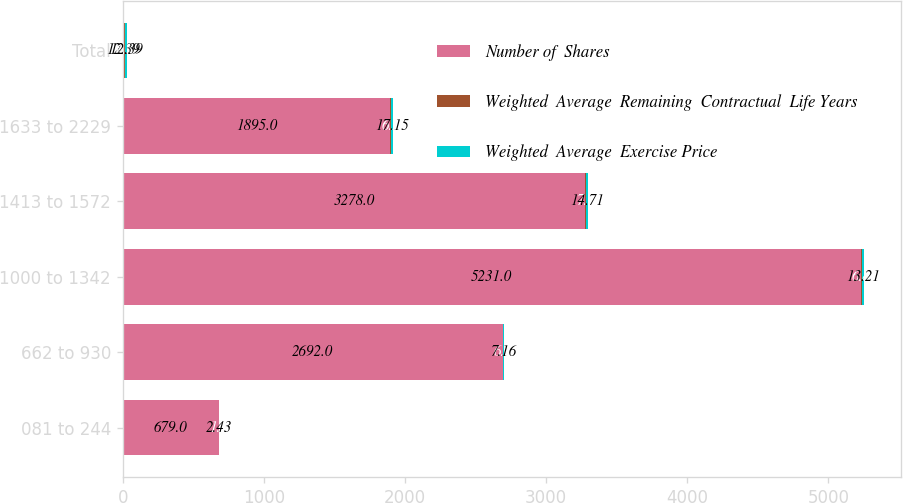<chart> <loc_0><loc_0><loc_500><loc_500><stacked_bar_chart><ecel><fcel>081 to 244<fcel>662 to 930<fcel>1000 to 1342<fcel>1413 to 1572<fcel>1633 to 2229<fcel>Total<nl><fcel>Number of  Shares<fcel>679<fcel>2692<fcel>5231<fcel>3278<fcel>1895<fcel>12.39<nl><fcel>Weighted  Average  Remaining  Contractual  Life Years<fcel>1<fcel>6<fcel>6.8<fcel>7.1<fcel>6.2<fcel>6.3<nl><fcel>Weighted  Average  Exercise Price<fcel>2.43<fcel>7.16<fcel>13.21<fcel>14.71<fcel>17.15<fcel>12.39<nl></chart> 